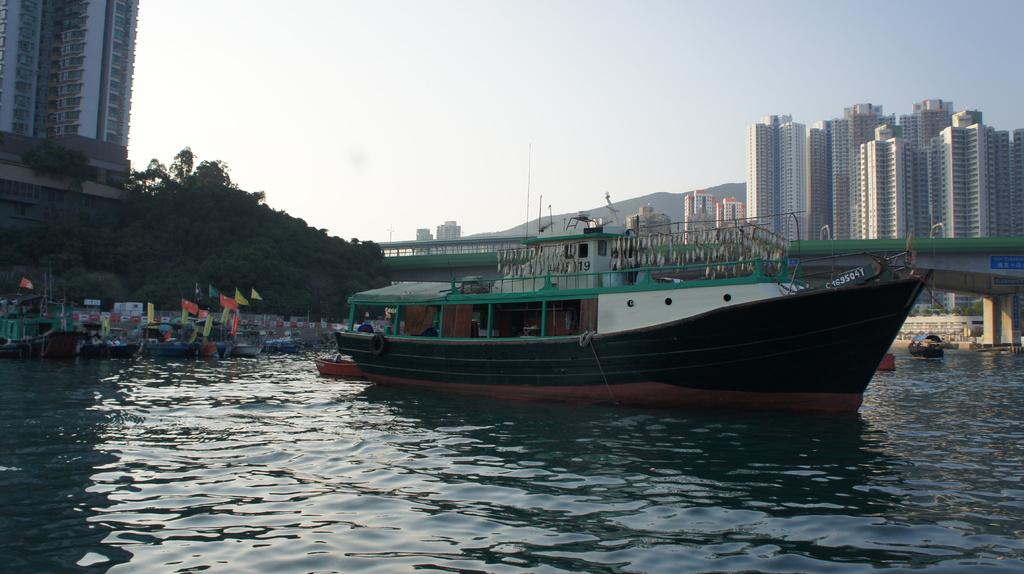What are the 2 black number on the cabin, that are visible?
Make the answer very short. 19. 